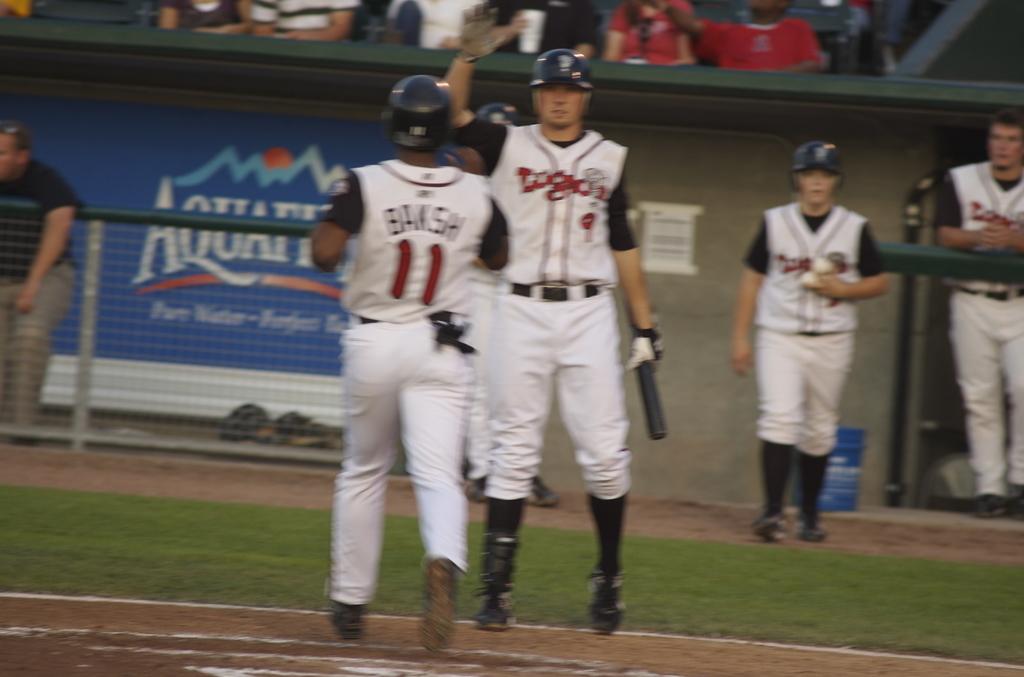Who is number 11?
Provide a succinct answer. Baksh. 